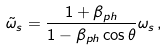Convert formula to latex. <formula><loc_0><loc_0><loc_500><loc_500>\tilde { \omega } _ { s } = \frac { 1 + \beta _ { p h } } { 1 - \beta _ { p h } \cos \theta } \omega _ { s } \, ,</formula> 